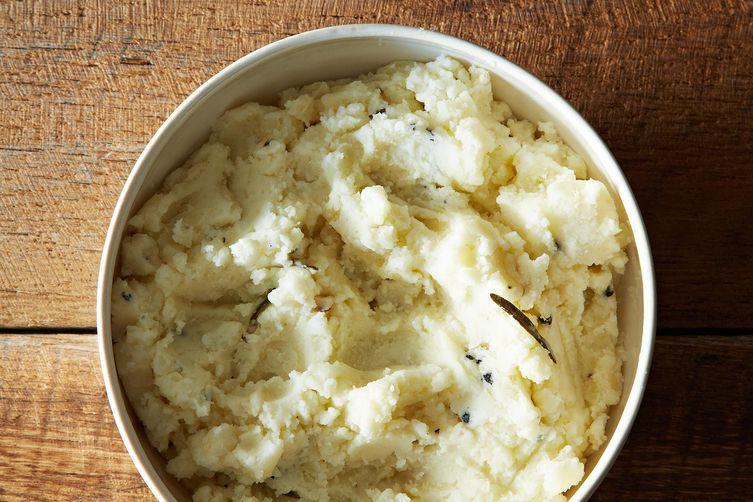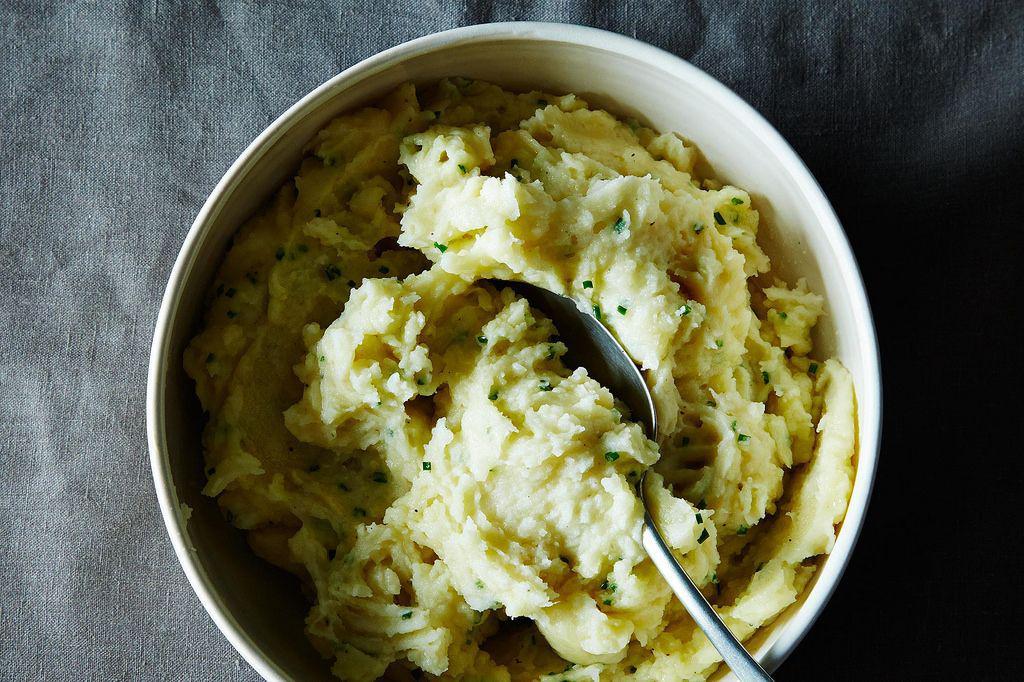The first image is the image on the left, the second image is the image on the right. Assess this claim about the two images: "Left image shows mashed potatoes in a round bowl with fluted edges.". Correct or not? Answer yes or no. No. 